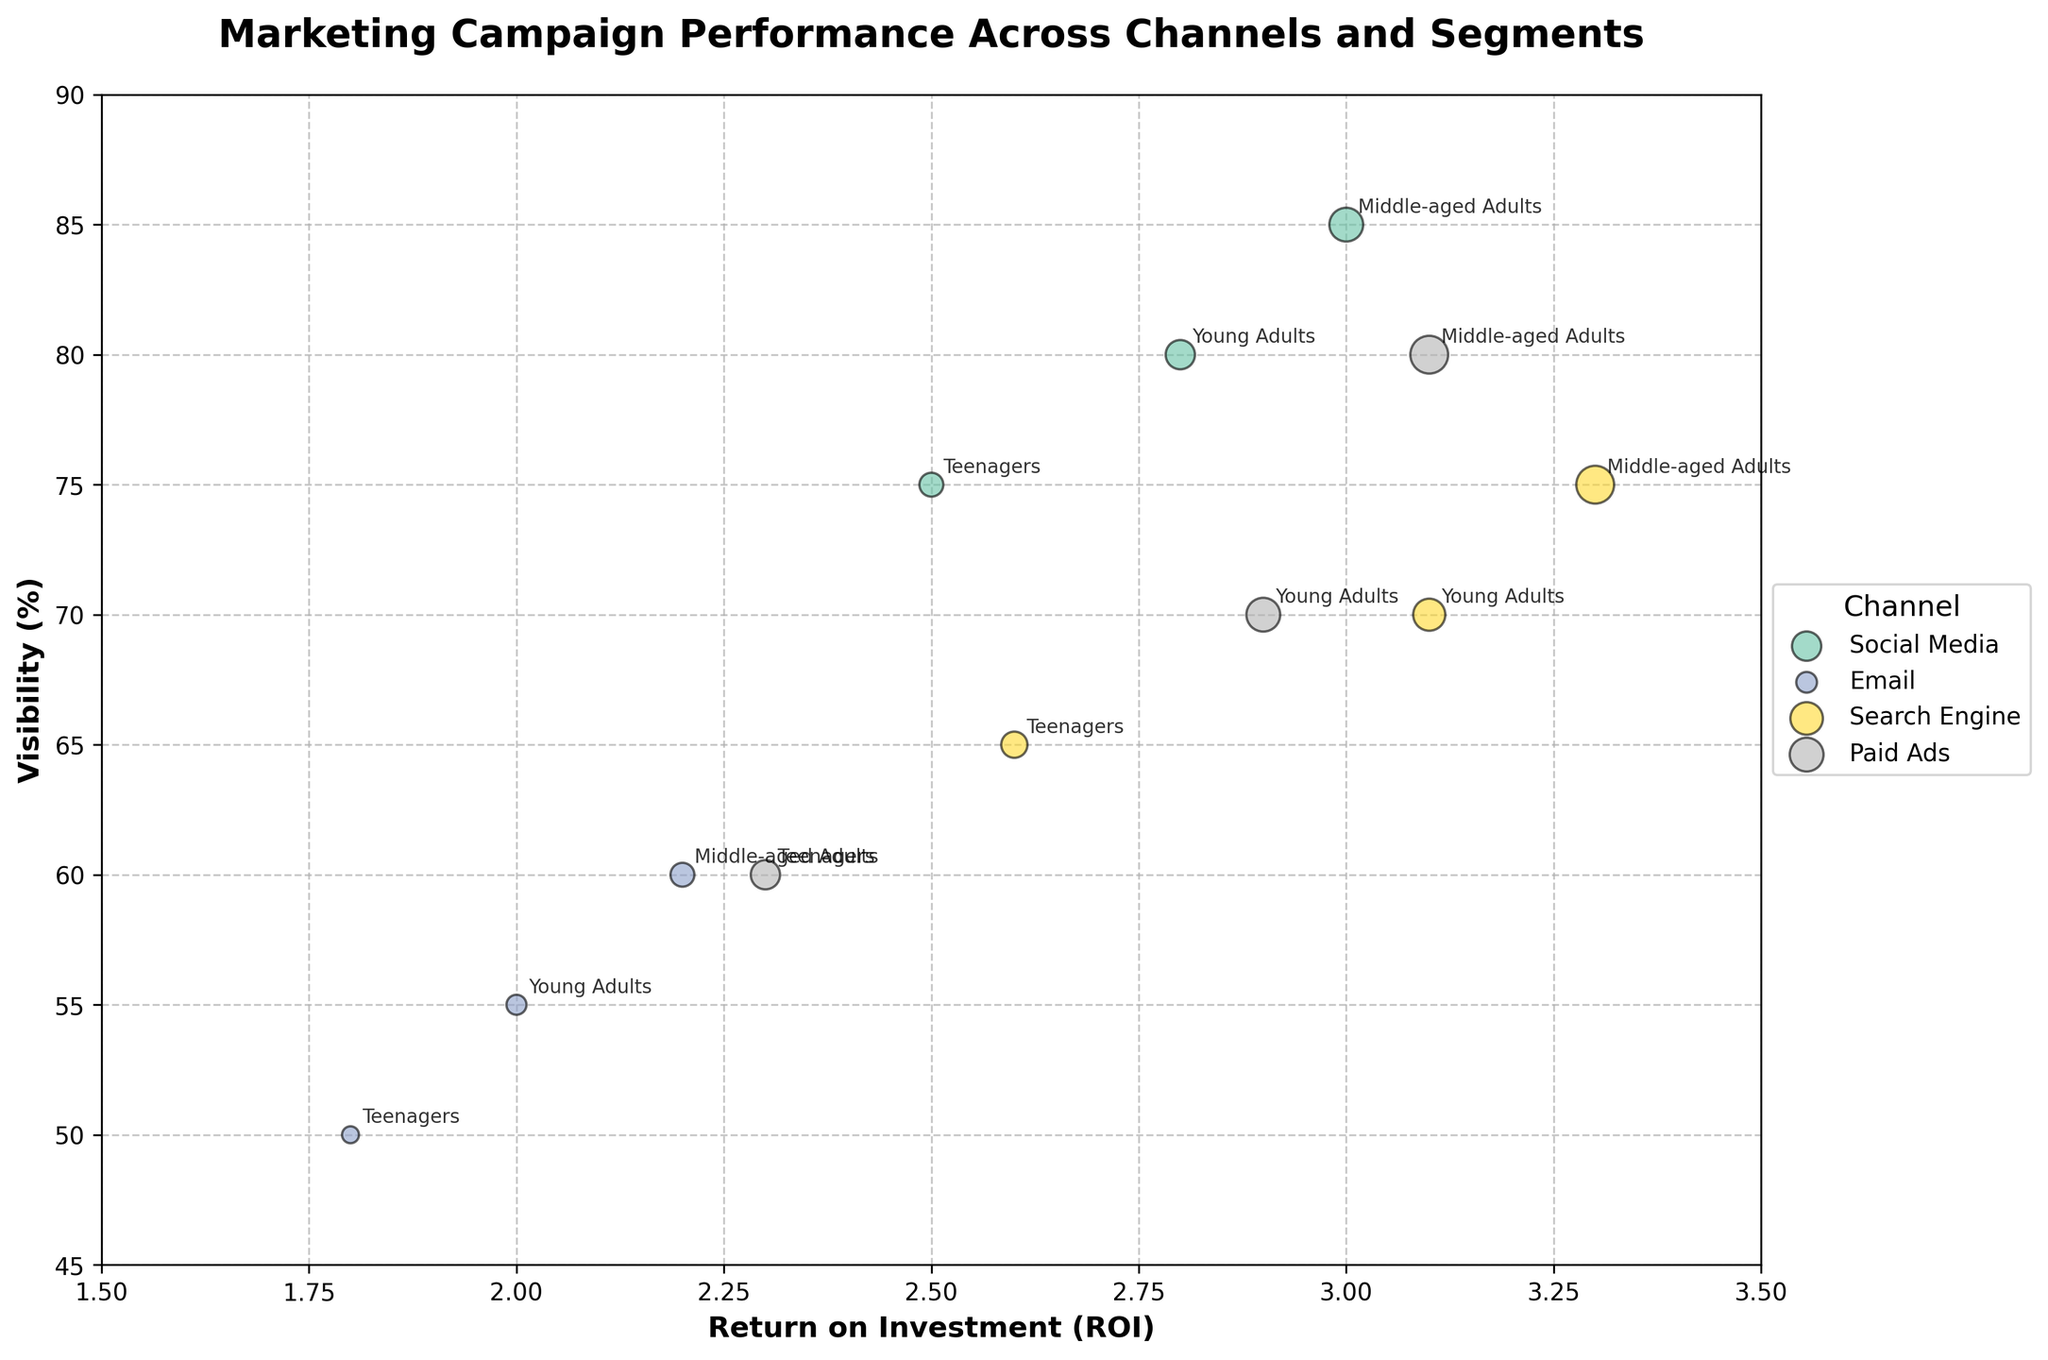What's the title of the chart? The title is written at the top of the chart and provides an overview of what the chart represents.
Answer: Marketing Campaign Performance Across Channels and Segments What do the axes represent? The x-axis represents the Return on Investment (ROI) and the y-axis represents Visibility (%). These are labeled on the chart.
Answer: ROI and Visibility (%) Which market segment for Social Media has the highest visibility? Locate the Social Media bubbles, then look for the bubble with the highest position on the y-axis.
Answer: Middle-aged Adults What is the average ROI for Paid Ads across all market segments? Identify the bubbles for Paid Ads and note their respective ROI values. Calculate the average of these values: (2.3 + 2.9 + 3.1)/3.
Answer: 2.77 Which channel has the highest visibility for Teenagers? Find the visibility percentage for each channel (Social Media, Email, Search Engine, Paid Ads) under the Teenagers segment. Compare these values and choose the highest one.
Answer: Social Media What is the total budget allocated for Email campaigns across all market segments? Sum the budget allocated for Email campaigns in all segments: 5000 + 7000 + 10000.
Answer: 22000 Which channel has the highest overall ROI, and what is that value? Compare the maximum ROI value of each channel and identify the highest one. For Social Media, the highest ROI is 3.0; for Email, it is 2.2; for Search Engine, it is 3.3; and for Paid Ads, it is 3.1.
Answer: Search Engine with an ROI of 3.3 How does the visibility for Young Adults compare between Social Media and Search Engine? Look at the y-axis values for Young Adults under Social Media (80%) and Search Engine (70%). Compare these values to see which is higher.
Answer: Social Media has higher visibility Which market segment has the smallest bubble for Search Engine, and what does it represent? The size of the bubble correlates with the budget. Identify the smallest bubble for Search Engine and the market segment it represents (Teenagers) and its corresponding budget (12000).
Answer: Teenagers, representing a budget of $12000 